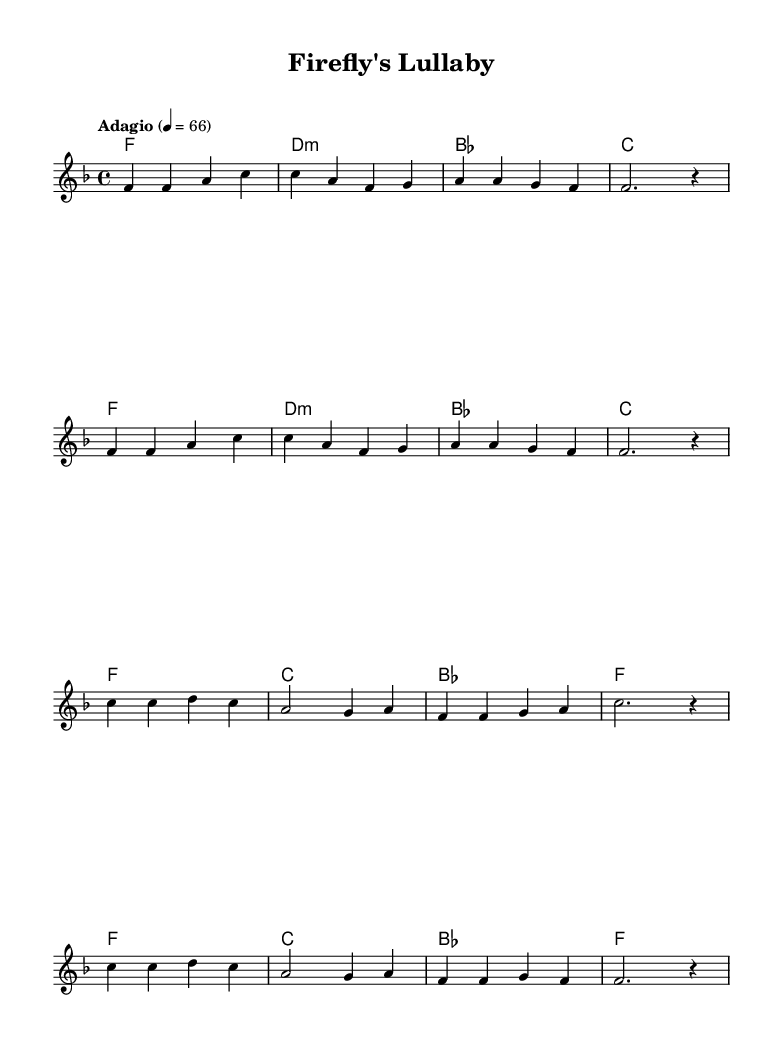What is the key signature of this music? The key signature is F major, which contains one flat (B flat). This can be determined by looking at the key signature indicated at the beginning of the score.
Answer: F major What is the time signature of this music? The time signature is 4/4, indicating that there are four beats in each measure, which is visible at the start of the score after the key signature.
Answer: 4/4 What is the tempo marking for this piece? The tempo marking is "Adagio", which indicates a slow tempo. This information is expressed at the beginning of the score, giving performers guidance on how fast to play the piece.
Answer: Adagio How many measures are in the verse section? The verse section contains eight measures, as indicated by the number of grouped music symbols before transitioning to the chorus section. Each section is visually separated by contrasts in the melody.
Answer: Eight Which chord is played in the first measure? The chord played in the first measure is F major, represented by the chord symbol notated above the staff. This is the first chord listed in the harmonies section, which appears in the score.
Answer: F major What is the last chord in the chorus section? The last chord in the chorus section is F major, which can be identified by looking at the harmony part corresponding to the final measure of the chorus. This observation requires recognizing the structure of the music.
Answer: F major What lyrical style is indicated in the score? The lyrical style indicated is a placeholder with no specific words, as shown by the repeated skips in the lyrics under the melody. This suggests that the lyrics have not been finalized or are illustrative.
Answer: Placeholder 